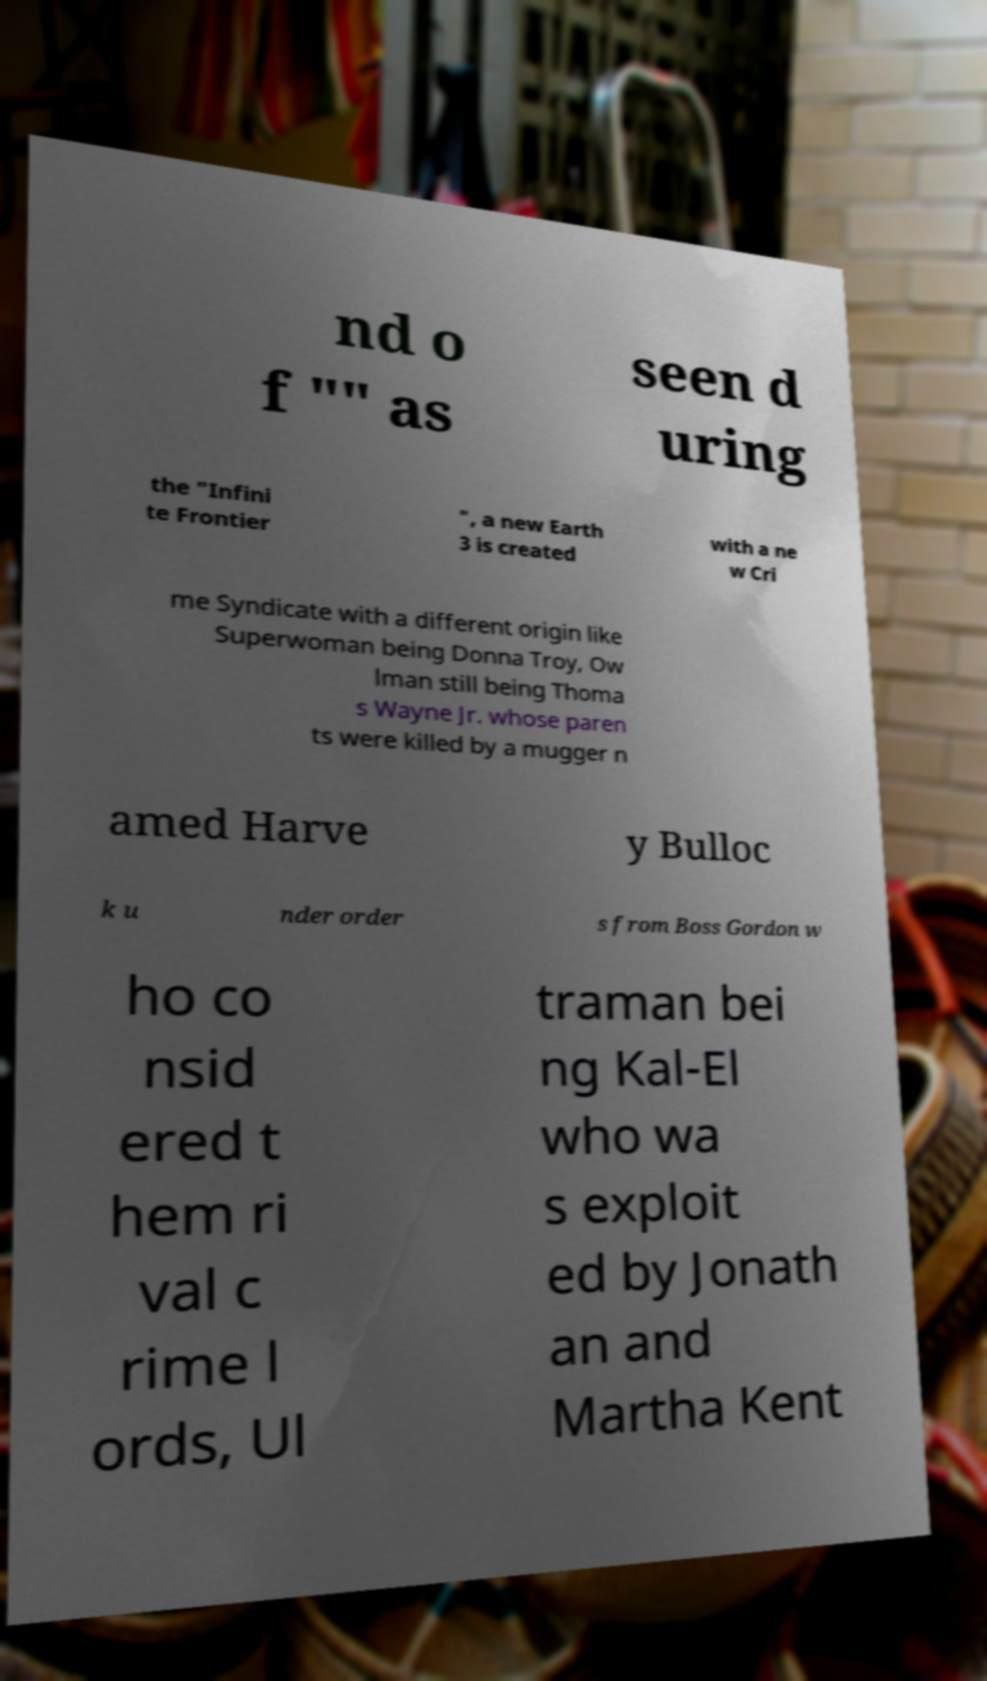Can you accurately transcribe the text from the provided image for me? nd o f "" as seen d uring the "Infini te Frontier ", a new Earth 3 is created with a ne w Cri me Syndicate with a different origin like Superwoman being Donna Troy, Ow lman still being Thoma s Wayne Jr. whose paren ts were killed by a mugger n amed Harve y Bulloc k u nder order s from Boss Gordon w ho co nsid ered t hem ri val c rime l ords, Ul traman bei ng Kal-El who wa s exploit ed by Jonath an and Martha Kent 